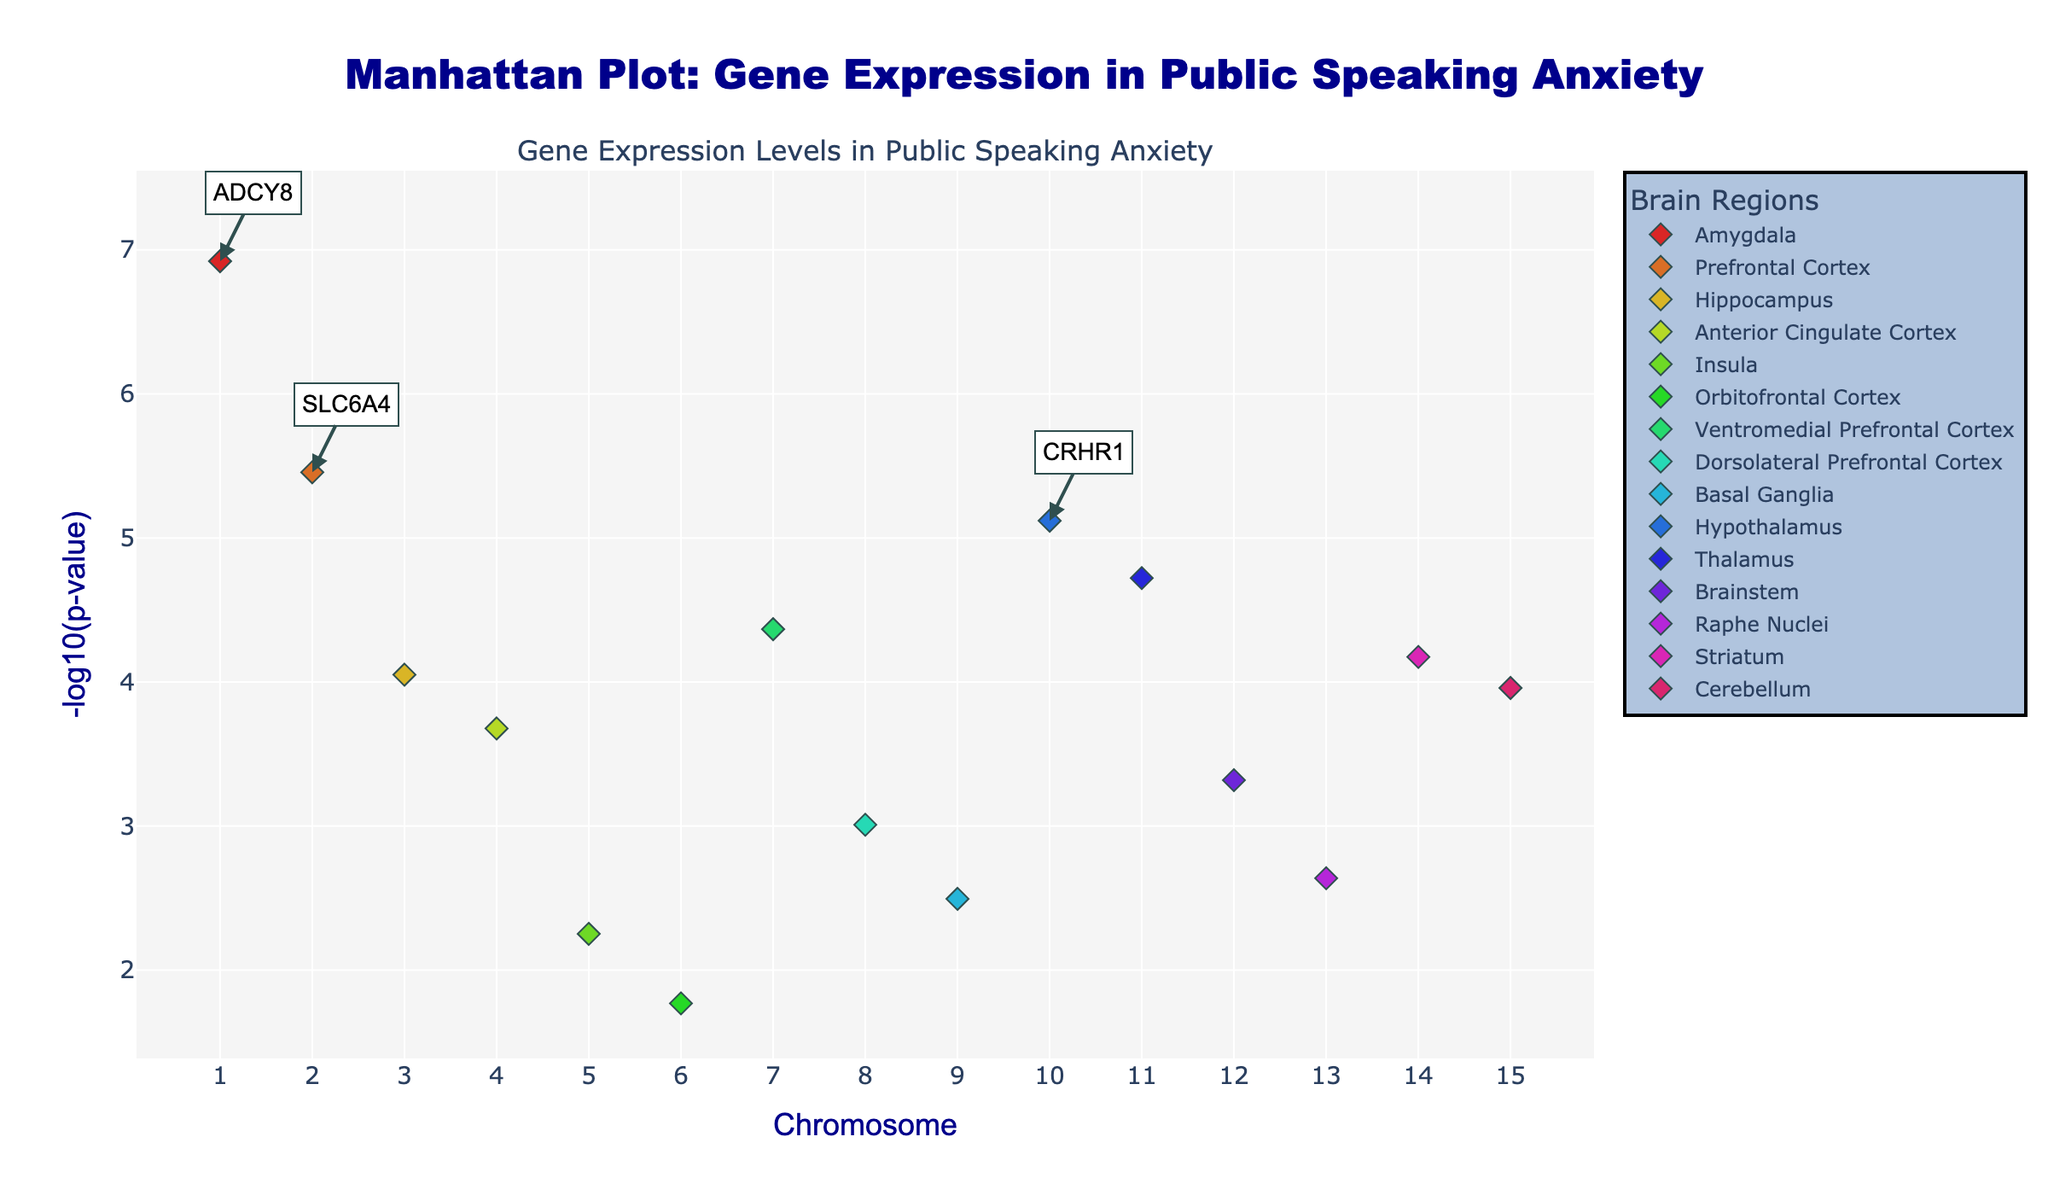What is the title of the plot? The title can be found at the top of the plot. It generally provides a brief description of what the plot is about. Here, the title is "Manhattan Plot: Gene Expression in Public Speaking Anxiety".
Answer: Manhattan Plot: Gene Expression in Public Speaking Anxiety Which chromosome has the gene with the lowest P-value? The lower the p-value, the higher will its -log10(p-value) representation be in the plot. Locate the highest point on the y-axis to determine the gene with the lowest p-value. This point lies on chromosome 1 for the gene ADCY8.
Answer: Chromosome 1 How many brain regions are represented in the plot? Brain regions are indicated in the legend. To count the number of different brain regions represented, refer to the legend which lists them all. There are 14 unique brain regions.
Answer: 14 Which brain region has the highest number of significant genes? To find the brain region with the highest number of significant genes, observe the scatter points for each brain region and count them. The Amygdala and the Prefrontal Cortex have equal numbers, each with one significant gene.
Answer: Amygdala and Prefrontal Cortex (Tie) What is the color associated with the Ventromedial Prefrontal Cortex? Color for each brain region is indicated by the legend. The Ventromedial Prefrontal Cortex color is an HSL value assigned earlier in the provided code and appears as a unique color in the plot.
Answer: Ventromedial Prefrontal Cortex Which gene in the Striatum has the highest -log10(p-value)? Locate the chromosome number for Striatum in the legend, and identify the point in the plot corresponding to that chromosome with the highest -log10(p-value). The gene in Striatum with the highest -log10(p-value) is DRD2.
Answer: DRD2 Is the gene COMT more significant in the Hippocampus or the gene TPH2 in the Raphe Nuclei? Compare the -log10(p-value) for both genes; the gene with the higher -log10(p-value) is more significant. COMT has a higher -log10(p-value) than TPH2.
Answer: COMT in Hippocampus Which gene in the top 3 significant genes is located on the highest numbered chromosome? Three genes with the highest -log10(p-value) are identified with annotations: ADCY8, SLC6A4, and CRHR1. Compare their chromosome numbers to find the gene on the highest numbered chromosome, which is CRHR1 on chromosome 10.
Answer: CRHR1 How many points on the plot have a -log10(p-value) greater than 5? Count the number of points above the horizontal line marking -log10(p-value) > 5. The data points to count include ADCY8, SLC6A4, CRHR1, and GABRA6, totaling 4 points.
Answer: 4 Which brain region has the least significant gene expression as per the Manhattan plot? Determine the brain region with the gene having the lowest -log10(p-value) by finding the lowest point on the y-axis. This suggests that the Orbitofrontal Cortex gene OXTR has the least significance.
Answer: Orbitofrontal Cortex 